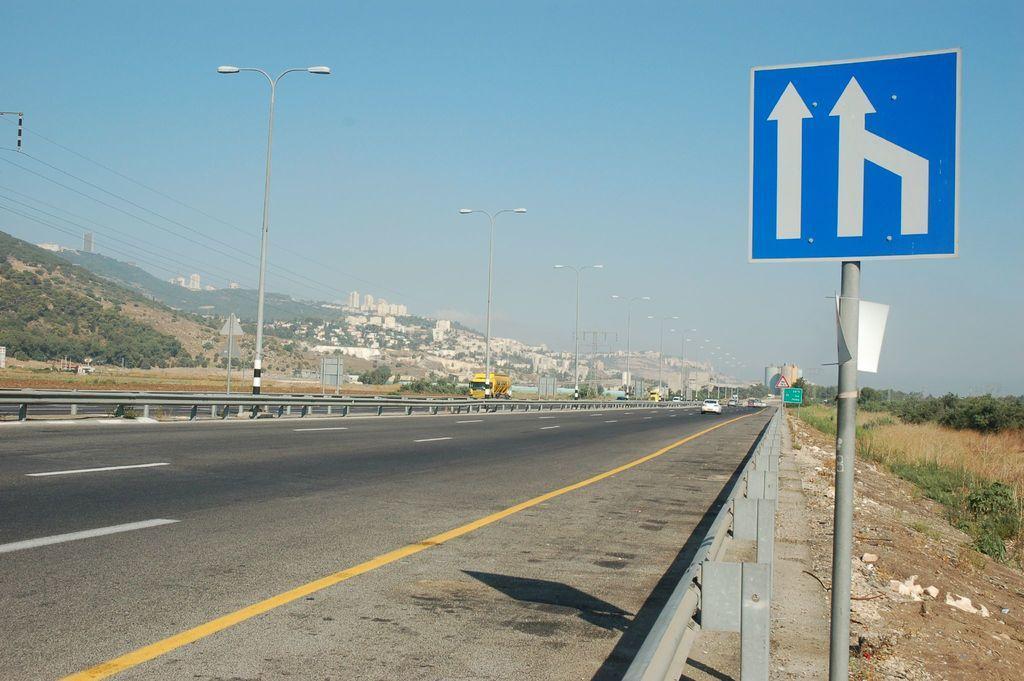Please provide a concise description of this image. In this picture there are vehicles on the road and there are street lights. At the back there are buildings and trees and there are mountains. On the right side of the image there are boards on the poles and there are trees. At the top there is sky and there are wires. At the bottom there is a road and there is ground and there is grass. 